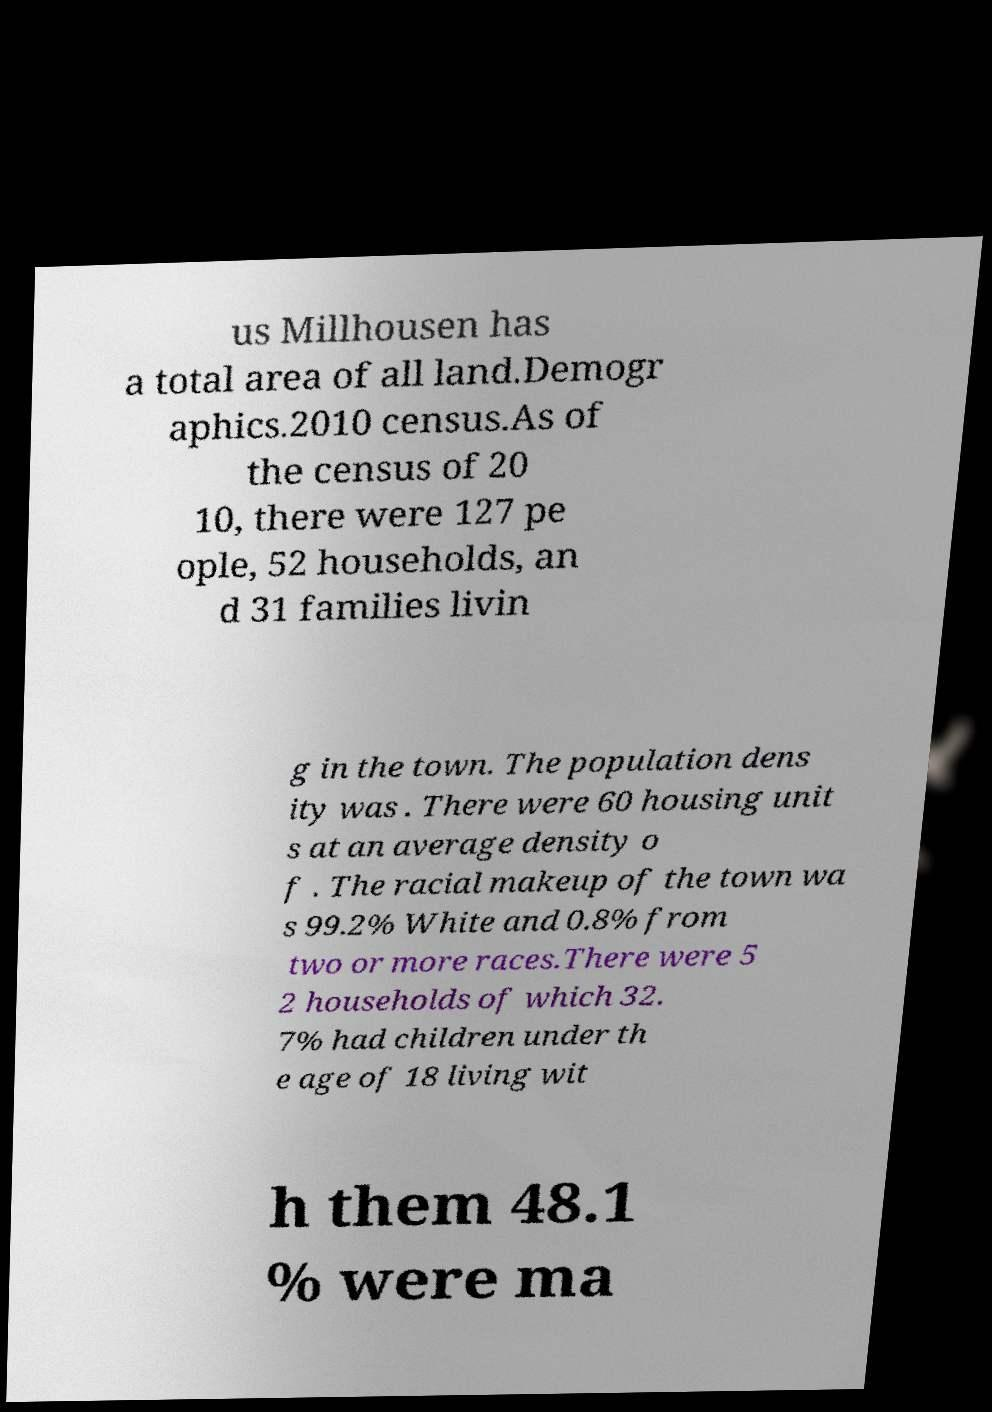There's text embedded in this image that I need extracted. Can you transcribe it verbatim? us Millhousen has a total area of all land.Demogr aphics.2010 census.As of the census of 20 10, there were 127 pe ople, 52 households, an d 31 families livin g in the town. The population dens ity was . There were 60 housing unit s at an average density o f . The racial makeup of the town wa s 99.2% White and 0.8% from two or more races.There were 5 2 households of which 32. 7% had children under th e age of 18 living wit h them 48.1 % were ma 